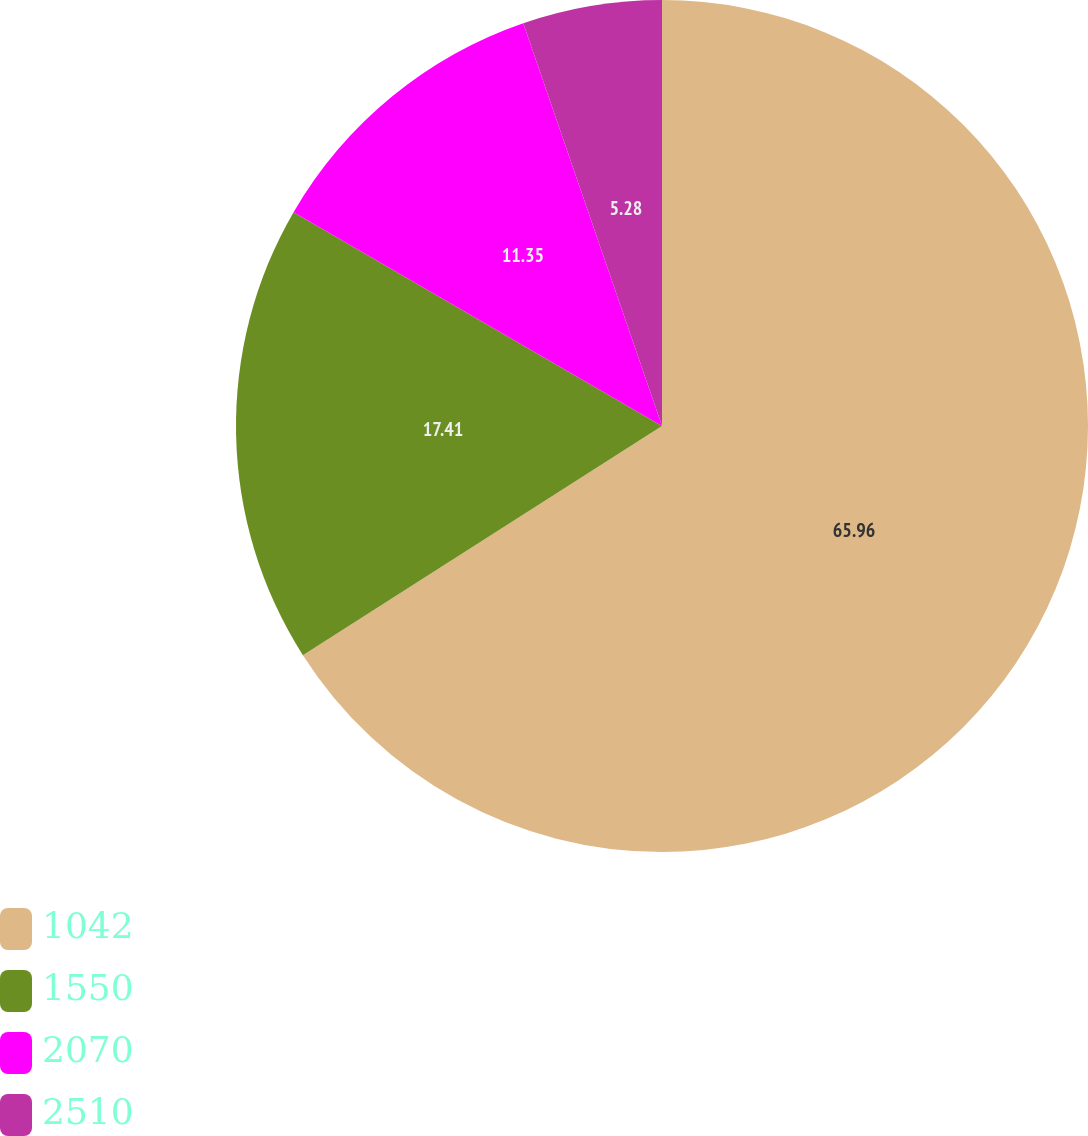Convert chart to OTSL. <chart><loc_0><loc_0><loc_500><loc_500><pie_chart><fcel>1042<fcel>1550<fcel>2070<fcel>2510<nl><fcel>65.96%<fcel>17.41%<fcel>11.35%<fcel>5.28%<nl></chart> 